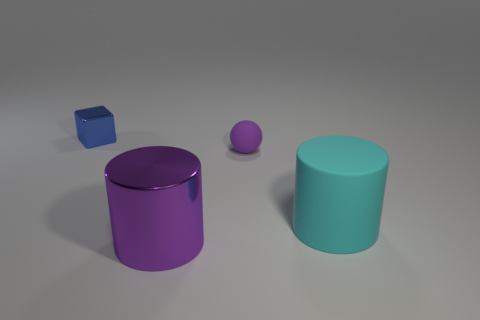What number of other objects are there of the same color as the rubber sphere?
Your answer should be compact. 1. Are the thing that is left of the big purple metallic cylinder and the cyan cylinder made of the same material?
Provide a short and direct response. No. There is a purple rubber object that is the same size as the shiny cube; what is its shape?
Ensure brevity in your answer.  Sphere. What number of spheres have the same color as the tiny metallic block?
Your response must be concise. 0. Are there fewer purple balls that are in front of the purple cylinder than tiny objects that are in front of the blue cube?
Make the answer very short. Yes. There is a purple cylinder; are there any metal things left of it?
Ensure brevity in your answer.  Yes. Is there a purple metallic cylinder that is to the right of the small object that is in front of the metal thing that is behind the large purple metallic cylinder?
Your answer should be compact. No. There is a small thing that is in front of the tiny blue metal cube; is its shape the same as the large purple thing?
Provide a short and direct response. No. There is a object that is made of the same material as the cyan cylinder; what is its color?
Provide a short and direct response. Purple. How many big things have the same material as the tiny block?
Your response must be concise. 1. 